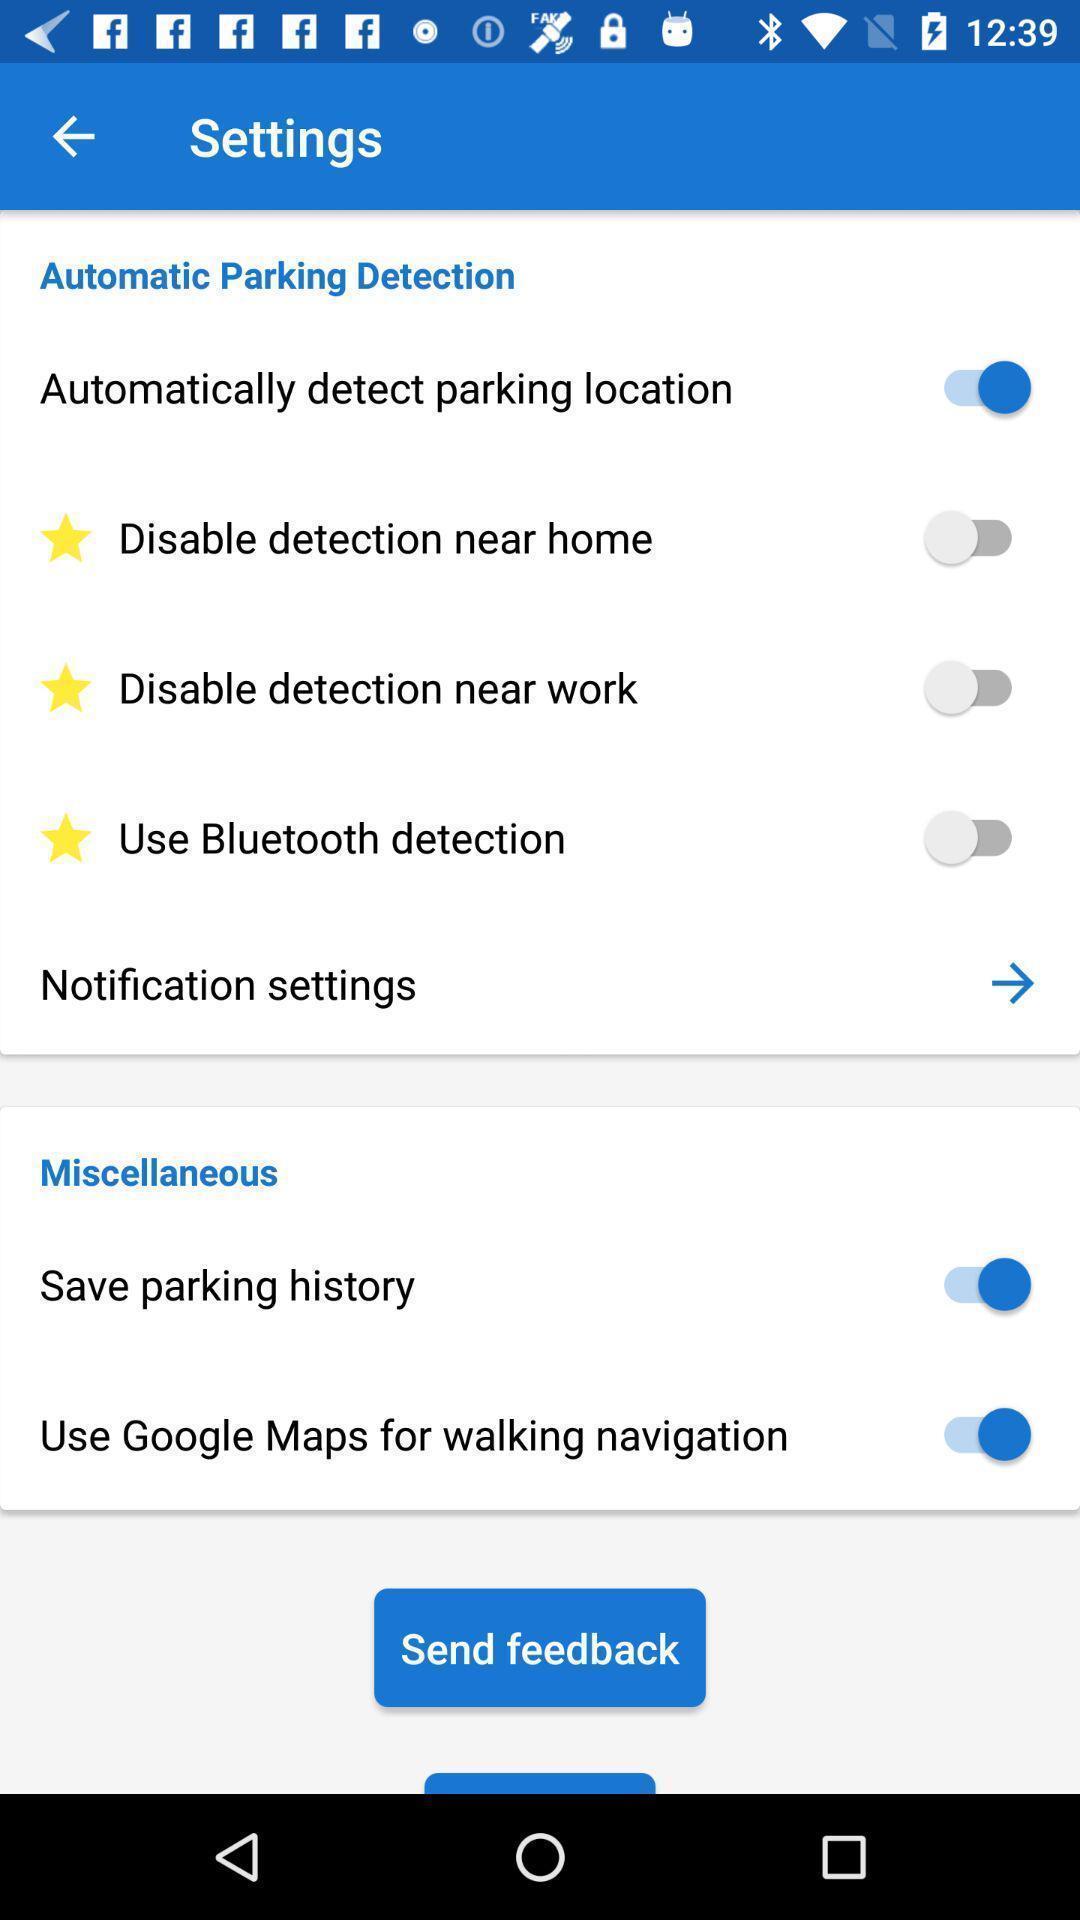Describe this image in words. Setting page displaying the various options. 